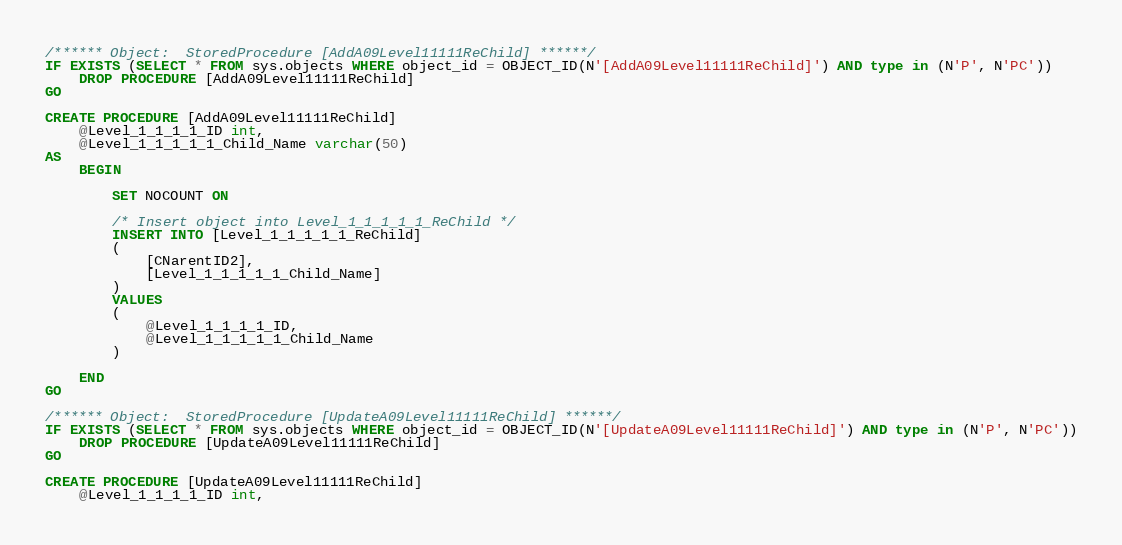<code> <loc_0><loc_0><loc_500><loc_500><_SQL_>/****** Object:  StoredProcedure [AddA09Level11111ReChild] ******/
IF EXISTS (SELECT * FROM sys.objects WHERE object_id = OBJECT_ID(N'[AddA09Level11111ReChild]') AND type in (N'P', N'PC'))
    DROP PROCEDURE [AddA09Level11111ReChild]
GO

CREATE PROCEDURE [AddA09Level11111ReChild]
    @Level_1_1_1_1_ID int,
    @Level_1_1_1_1_1_Child_Name varchar(50)
AS
    BEGIN

        SET NOCOUNT ON

        /* Insert object into Level_1_1_1_1_1_ReChild */
        INSERT INTO [Level_1_1_1_1_1_ReChild]
        (
            [CNarentID2],
            [Level_1_1_1_1_1_Child_Name]
        )
        VALUES
        (
            @Level_1_1_1_1_ID,
            @Level_1_1_1_1_1_Child_Name
        )

    END
GO

/****** Object:  StoredProcedure [UpdateA09Level11111ReChild] ******/
IF EXISTS (SELECT * FROM sys.objects WHERE object_id = OBJECT_ID(N'[UpdateA09Level11111ReChild]') AND type in (N'P', N'PC'))
    DROP PROCEDURE [UpdateA09Level11111ReChild]
GO

CREATE PROCEDURE [UpdateA09Level11111ReChild]
    @Level_1_1_1_1_ID int,</code> 